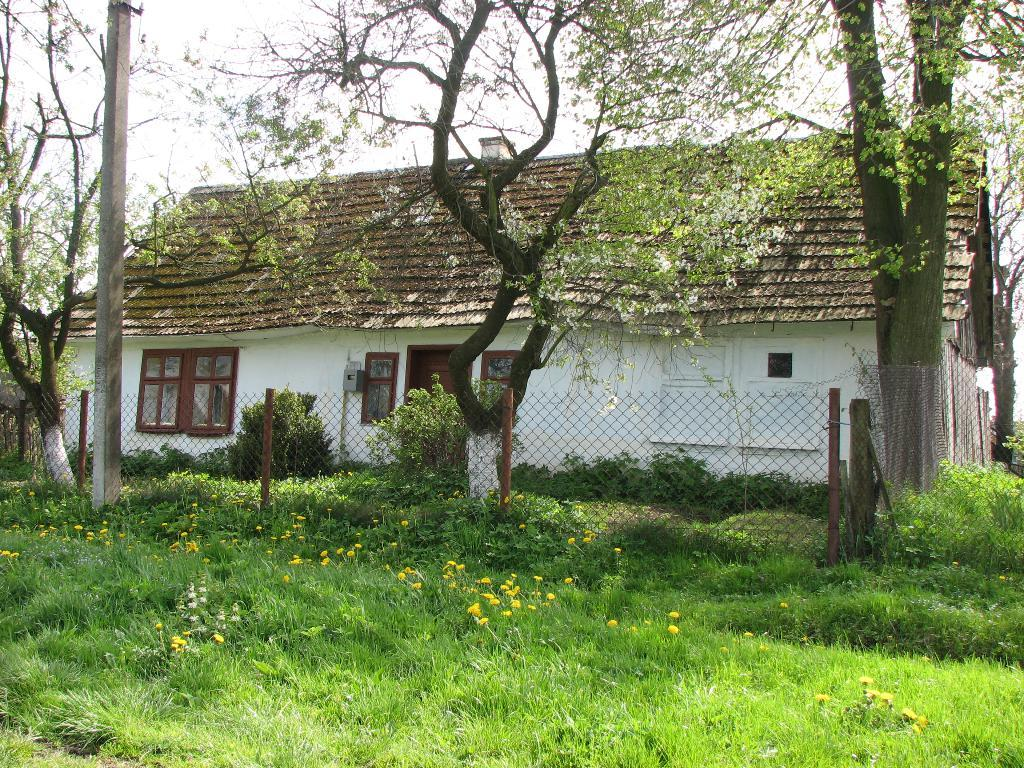What type of structure is present in the image? There is a house in the image. What features can be seen on the house? The house has windows. What type of vegetation is visible in the image? There are trees, plants, grass, and flowers in the image. What type of barrier is present in the image? There is a fence in the image. What type of shoes is the father wearing in the image? There is no father or shoes present in the image. Is the house located in space in the image? No, the house is not located in space; it is on a ground-level surface surrounded by vegetation. 